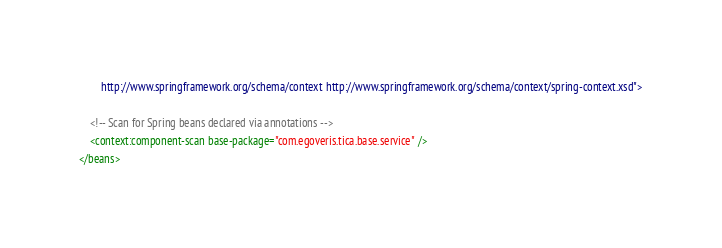Convert code to text. <code><loc_0><loc_0><loc_500><loc_500><_XML_>		http://www.springframework.org/schema/context http://www.springframework.org/schema/context/spring-context.xsd">

	<!-- Scan for Spring beans declared via annotations -->
	<context:component-scan base-package="com.egoveris.tica.base.service" />
</beans></code> 